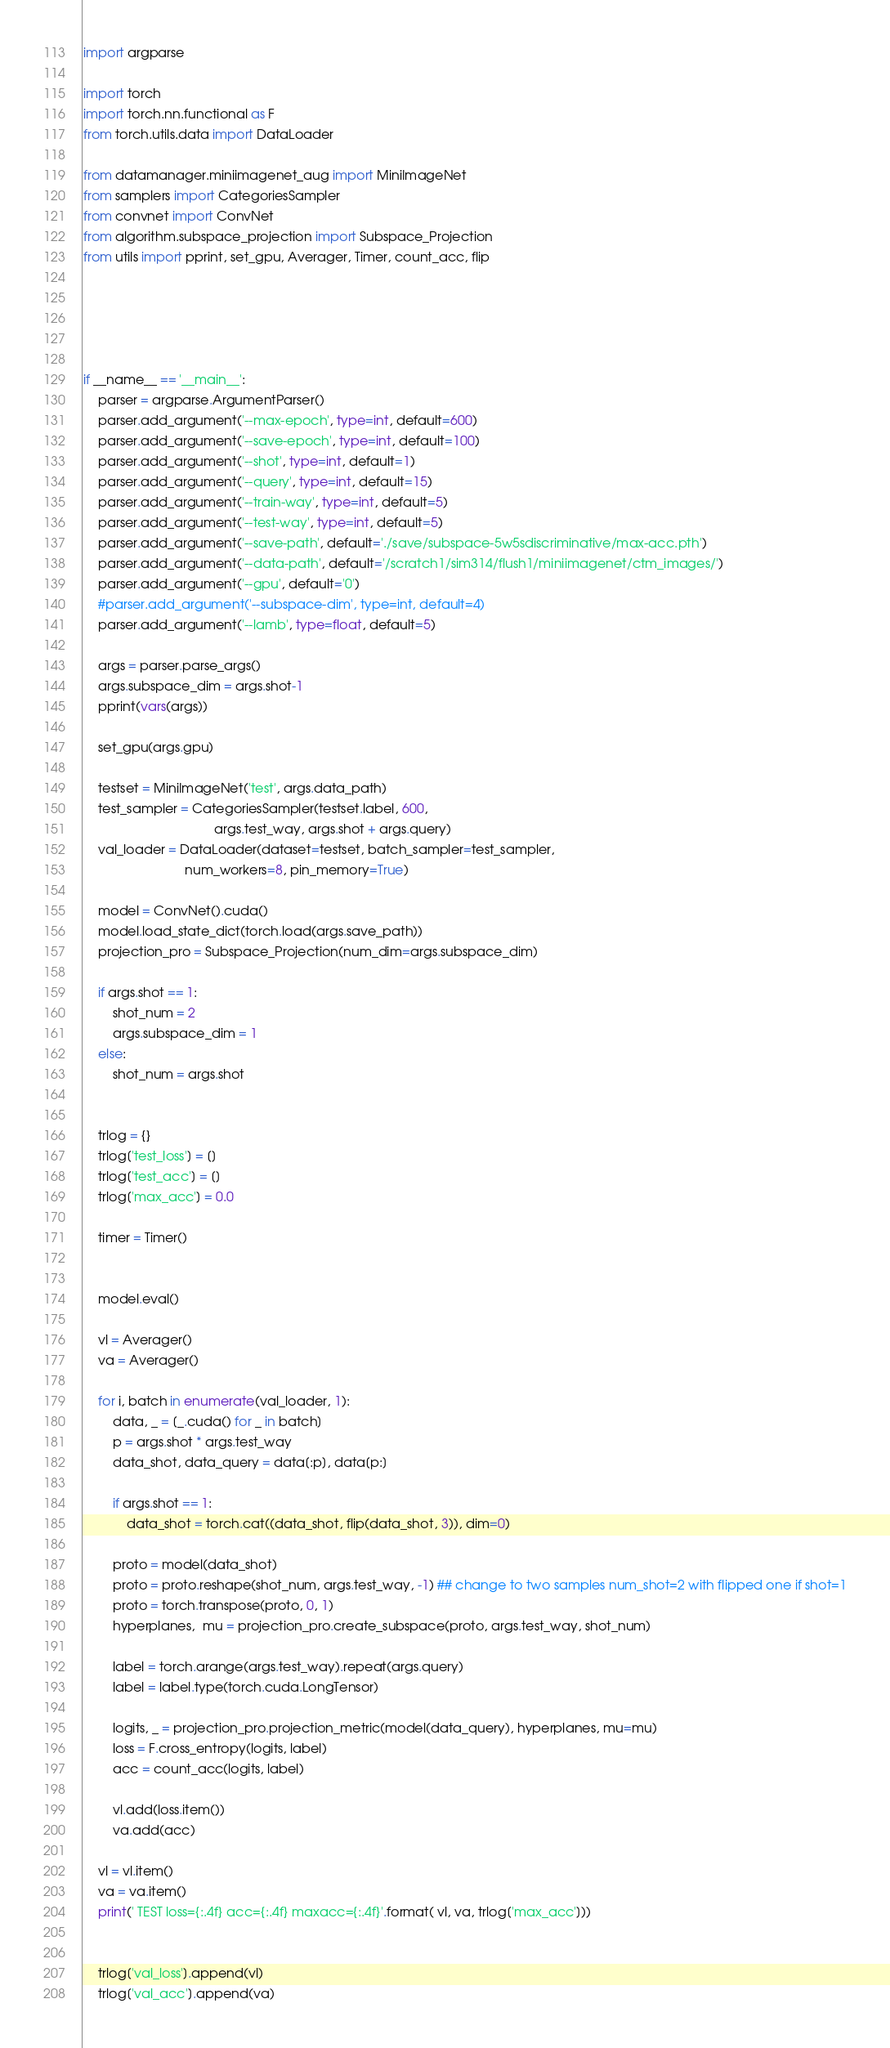Convert code to text. <code><loc_0><loc_0><loc_500><loc_500><_Python_>import argparse

import torch
import torch.nn.functional as F
from torch.utils.data import DataLoader

from datamanager.miniimagenet_aug import MiniImageNet
from samplers import CategoriesSampler
from convnet import ConvNet
from algorithm.subspace_projection import Subspace_Projection
from utils import pprint, set_gpu, Averager, Timer, count_acc, flip





if __name__ == '__main__':
    parser = argparse.ArgumentParser()
    parser.add_argument('--max-epoch', type=int, default=600)
    parser.add_argument('--save-epoch', type=int, default=100)
    parser.add_argument('--shot', type=int, default=1)
    parser.add_argument('--query', type=int, default=15)
    parser.add_argument('--train-way', type=int, default=5)
    parser.add_argument('--test-way', type=int, default=5)
    parser.add_argument('--save-path', default='./save/subspace-5w5sdiscriminative/max-acc.pth')
    parser.add_argument('--data-path', default='/scratch1/sim314/flush1/miniimagenet/ctm_images/')
    parser.add_argument('--gpu', default='0')
    #parser.add_argument('--subspace-dim', type=int, default=4)
    parser.add_argument('--lamb', type=float, default=5)

    args = parser.parse_args()
    args.subspace_dim = args.shot-1
    pprint(vars(args))

    set_gpu(args.gpu)

    testset = MiniImageNet('test', args.data_path)
    test_sampler = CategoriesSampler(testset.label, 600,
                                    args.test_way, args.shot + args.query)
    val_loader = DataLoader(dataset=testset, batch_sampler=test_sampler,
                            num_workers=8, pin_memory=True)

    model = ConvNet().cuda()
    model.load_state_dict(torch.load(args.save_path))
    projection_pro = Subspace_Projection(num_dim=args.subspace_dim)

    if args.shot == 1:
        shot_num = 2
        args.subspace_dim = 1
    else:
        shot_num = args.shot


    trlog = {}
    trlog['test_loss'] = []
    trlog['test_acc'] = []
    trlog['max_acc'] = 0.0

    timer = Timer()


    model.eval()

    vl = Averager()
    va = Averager()

    for i, batch in enumerate(val_loader, 1):
        data, _ = [_.cuda() for _ in batch]
        p = args.shot * args.test_way
        data_shot, data_query = data[:p], data[p:]

        if args.shot == 1:
            data_shot = torch.cat((data_shot, flip(data_shot, 3)), dim=0)

        proto = model(data_shot)
        proto = proto.reshape(shot_num, args.test_way, -1) ## change to two samples num_shot=2 with flipped one if shot=1
        proto = torch.transpose(proto, 0, 1)
        hyperplanes,  mu = projection_pro.create_subspace(proto, args.test_way, shot_num)

        label = torch.arange(args.test_way).repeat(args.query)
        label = label.type(torch.cuda.LongTensor)

        logits, _ = projection_pro.projection_metric(model(data_query), hyperplanes, mu=mu)
        loss = F.cross_entropy(logits, label)
        acc = count_acc(logits, label)

        vl.add(loss.item())
        va.add(acc)

    vl = vl.item()
    va = va.item()
    print(' TEST loss={:.4f} acc={:.4f} maxacc={:.4f}'.format( vl, va, trlog['max_acc']))


    trlog['val_loss'].append(vl)
    trlog['val_acc'].append(va)


</code> 